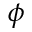<formula> <loc_0><loc_0><loc_500><loc_500>\phi</formula> 